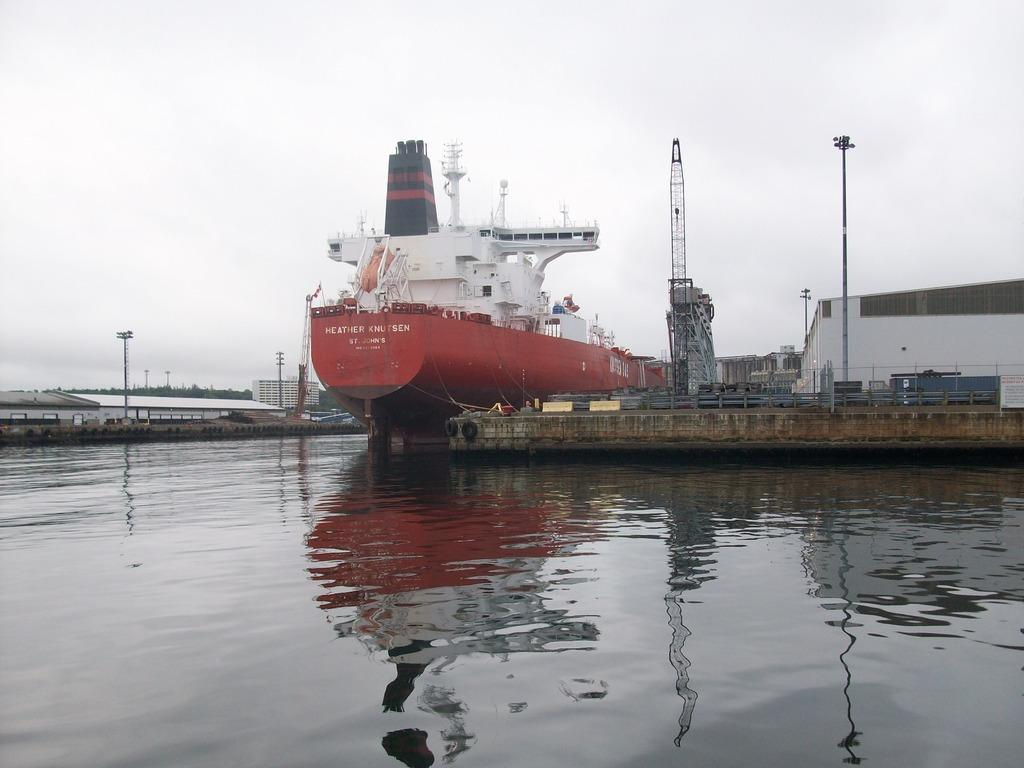<image>
Share a concise interpretation of the image provided. A red cargo ship Heather Knutsen at a dock. 